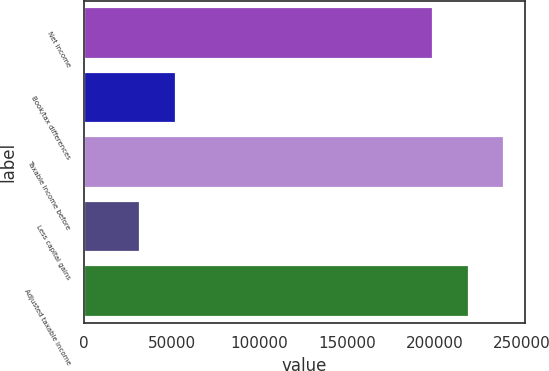Convert chart. <chart><loc_0><loc_0><loc_500><loc_500><bar_chart><fcel>Net income<fcel>Book/tax differences<fcel>Taxable income before<fcel>Less capital gains<fcel>Adjusted taxable income<nl><fcel>199232<fcel>52239.5<fcel>239693<fcel>32009<fcel>219462<nl></chart> 